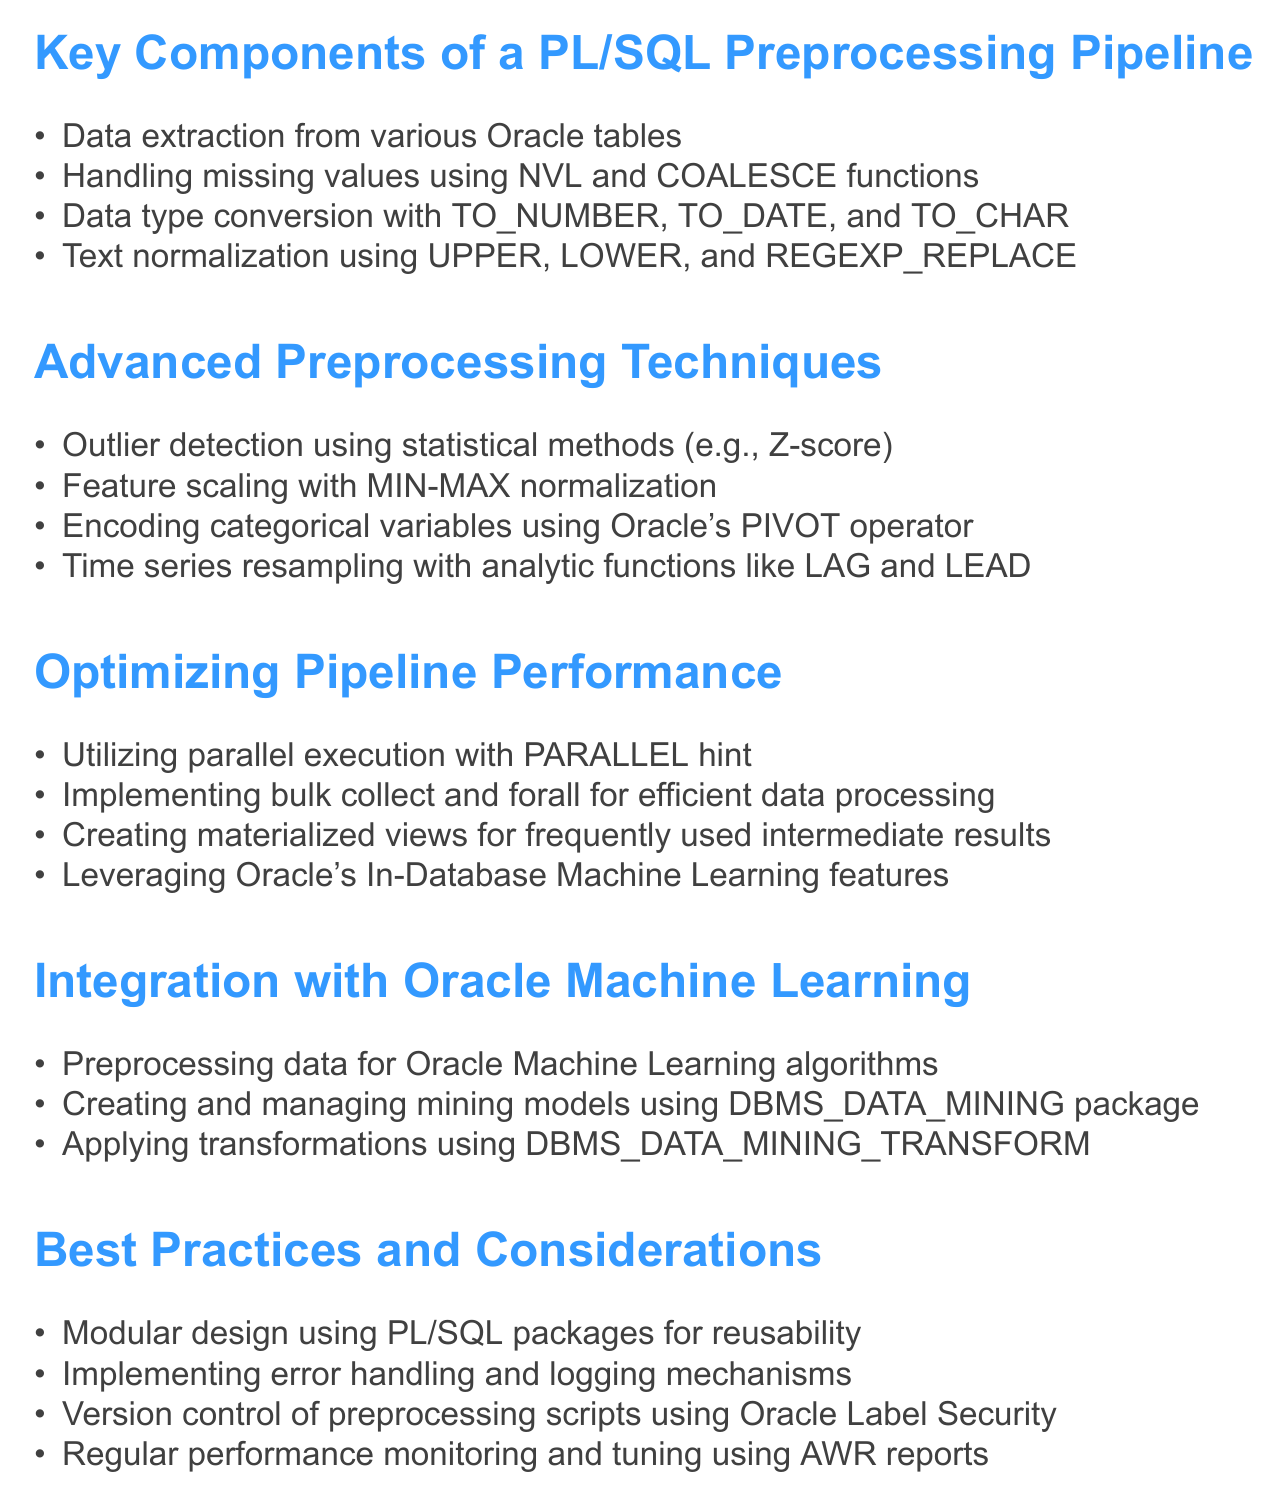What is the first key component of the PL/SQL preprocessing pipeline? The first key component listed in the document is data extraction from various Oracle tables.
Answer: Data extraction from various Oracle tables What statistical method is mentioned for outlier detection? The document specifies Z-score as a statistical method for outlier detection.
Answer: Z-score Which Oracle package is used for managing mining models? The document states that the DBMS_DATA_MINING package is used for creating and managing mining models.
Answer: DBMS_DATA_MINING What is suggested for efficient data processing in pipeline performance optimization? The document suggests implementing bulk collect and forall for efficient data processing.
Answer: Bulk collect and forall How many advanced preprocessing techniques are listed in the document? The document lists four advanced preprocessing techniques under the relevant section.
Answer: Four 